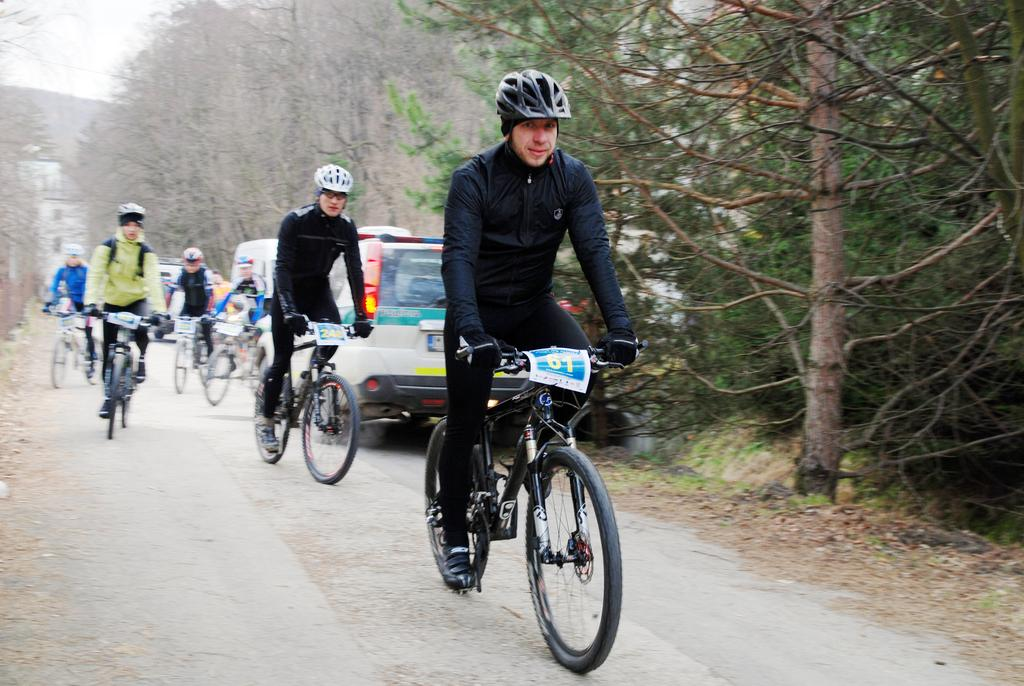What are the persons in the image doing? The persons in the image are riding bicycles. What else can be seen in the image besides the persons riding bicycles? There are vehicles and a group of trees in the image. What part of the sky is visible in the image? The sky is visible in the top left of the image. What type of temperament can be observed in the line of trees in the image? There is no line of trees in the image, and therefore no temperament can be observed. 